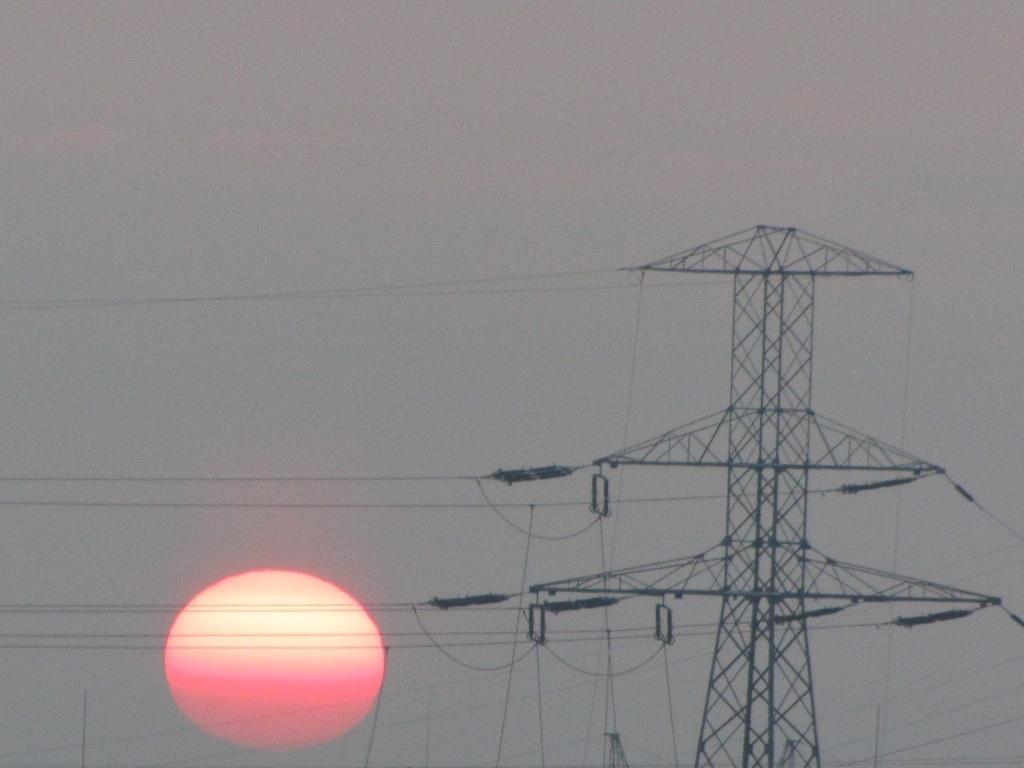In one or two sentences, can you explain what this image depicts? In this picture I can see there is a electric tower and it has some cables attached to it and in the backdrop I can see the sky is clear and there is sun. 